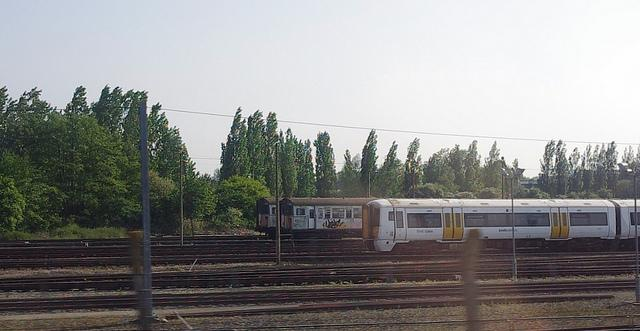During which time of the year are these trains operating? Please explain your reasoning. summer. It doesn't look cold. 